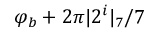Convert formula to latex. <formula><loc_0><loc_0><loc_500><loc_500>\varphi _ { b } + 2 \pi | 2 ^ { i } | _ { 7 } / 7</formula> 